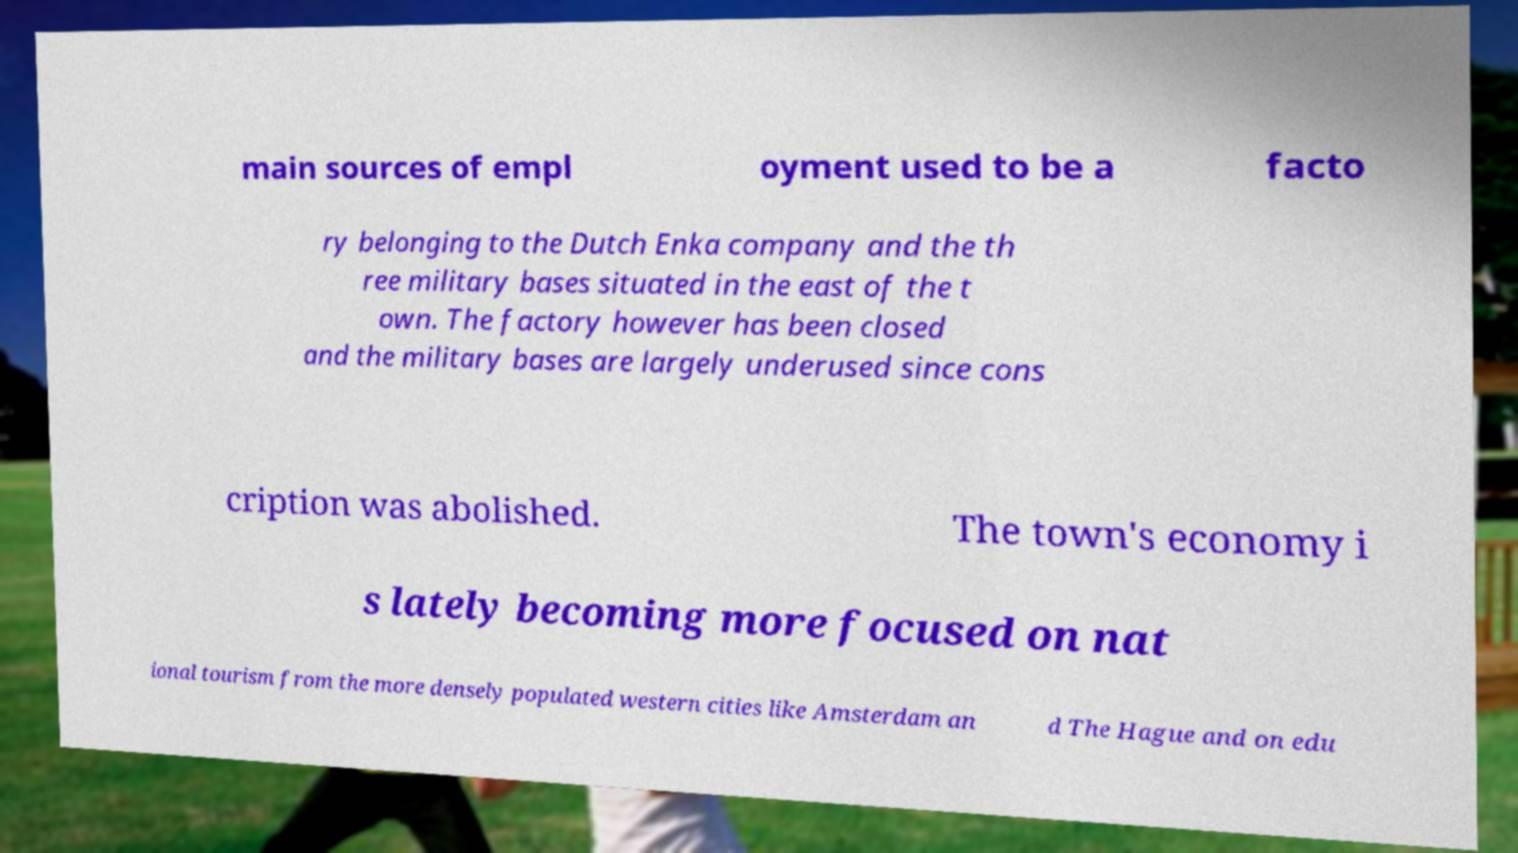Please identify and transcribe the text found in this image. main sources of empl oyment used to be a facto ry belonging to the Dutch Enka company and the th ree military bases situated in the east of the t own. The factory however has been closed and the military bases are largely underused since cons cription was abolished. The town's economy i s lately becoming more focused on nat ional tourism from the more densely populated western cities like Amsterdam an d The Hague and on edu 